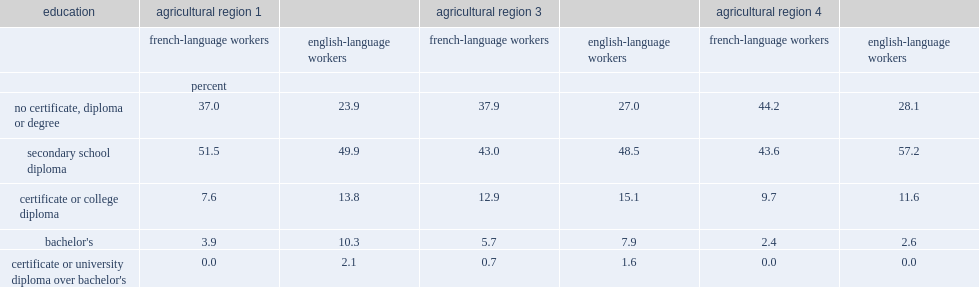Which sector of workers were more likely to have no certificate, diploma or degree in all three of new brunswick's agricultural regions? english-language workers or french-language workers? French-language workers. Which sector of workers had fewer workers who attained the highest level of education? french-language workers or english-language colleagues? French-language workers. Which sector of workers had fewer workers who attained a least a high school diploma? french-language workers or english language workers? French-language workers. 